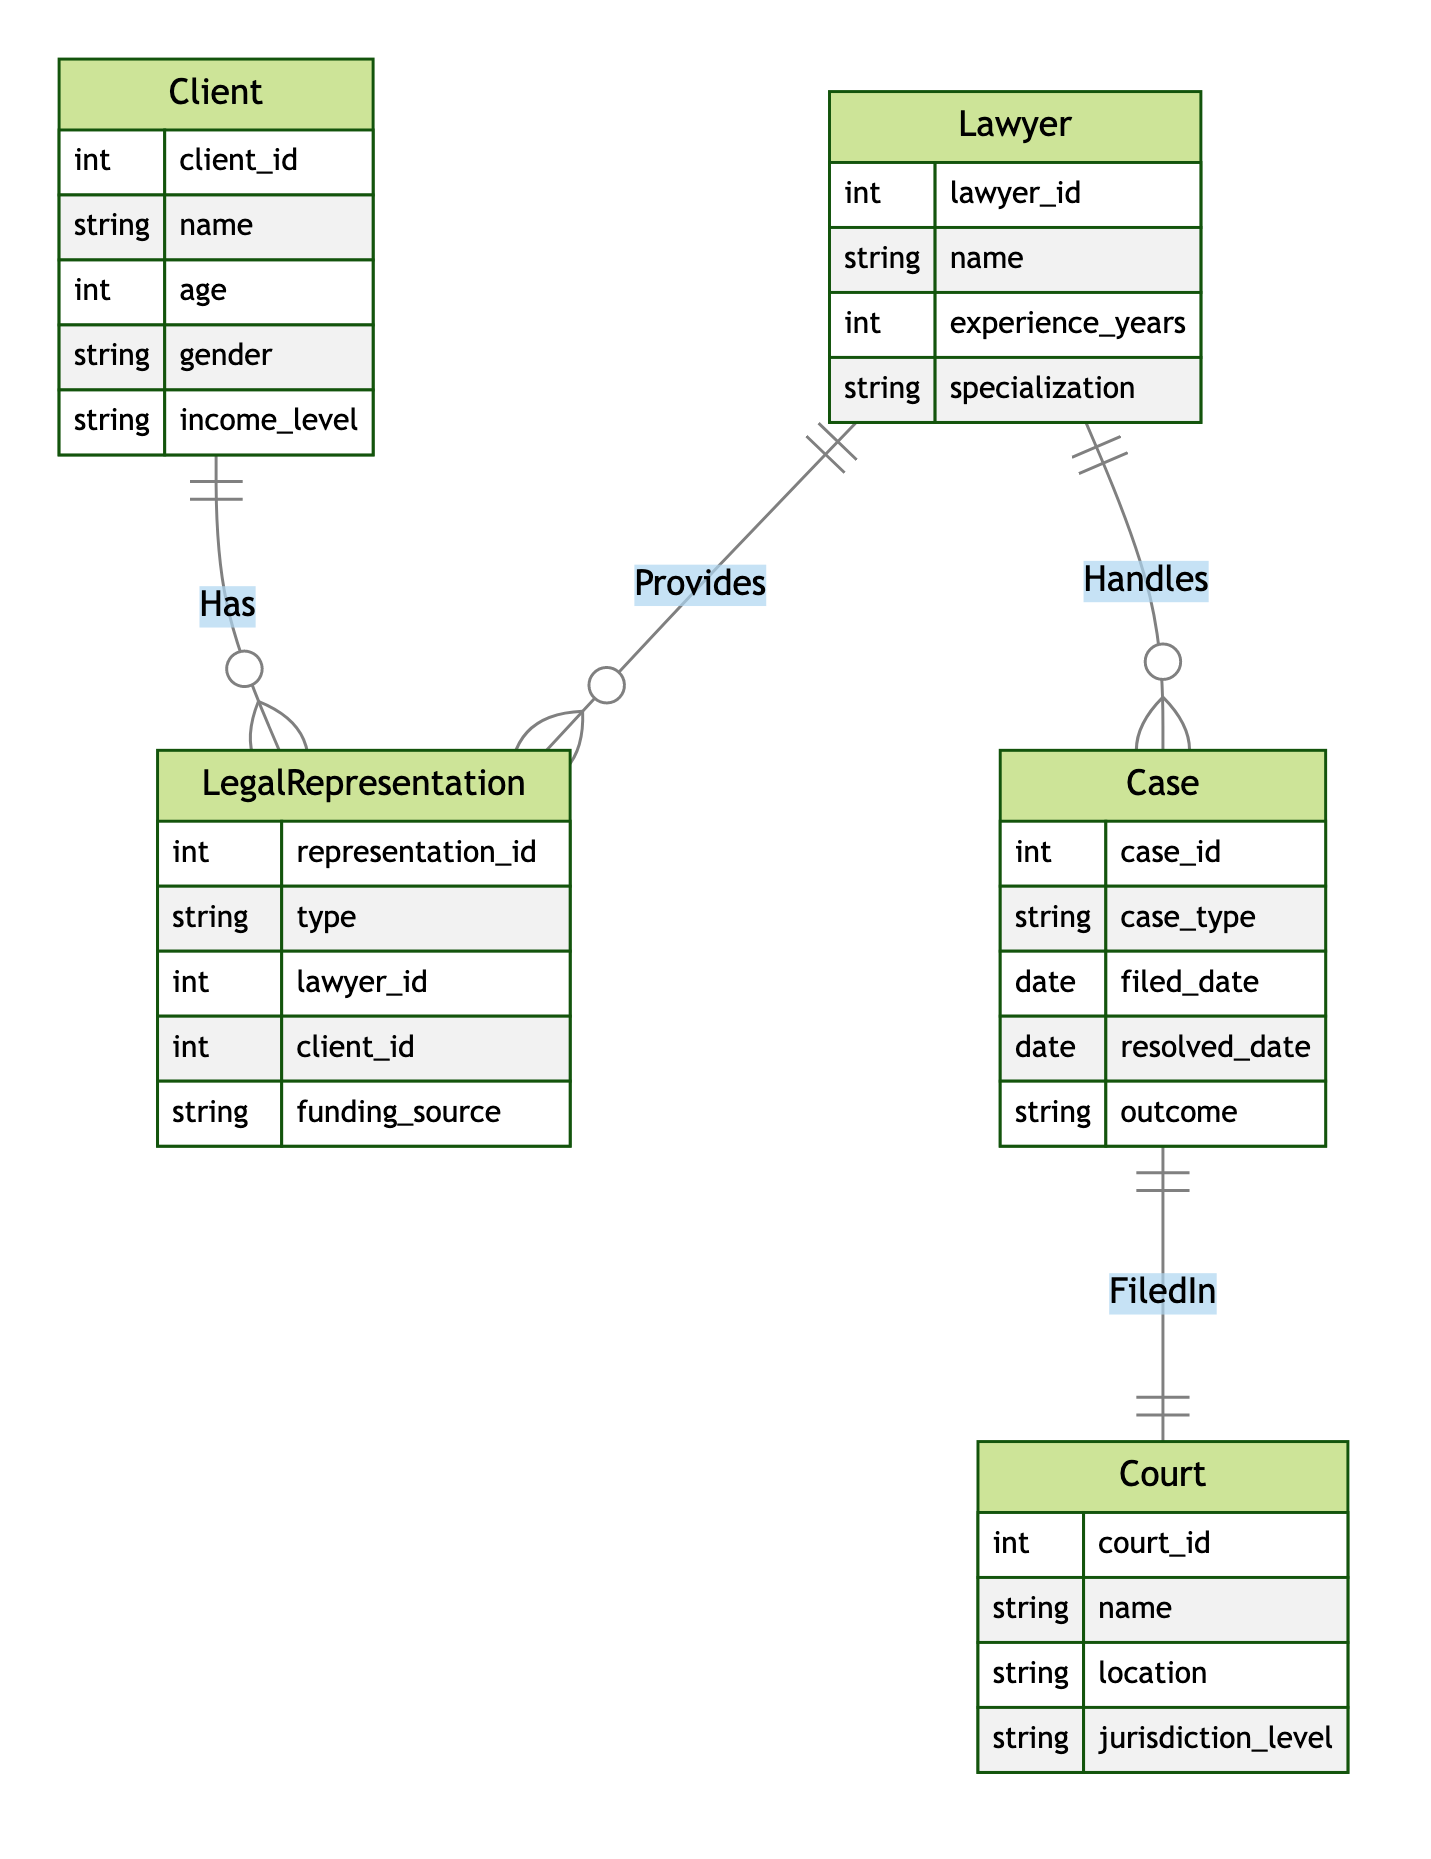What is the primary relationship between Lawyer and Client? In the diagram, the relationship is labeled "Represents", which indicates that a lawyer represents a client as part of their legal representation.
Answer: Represents How many attributes are associated with the Case entity? The Case entity has five attributes: case_id, case_type, filed_date, resolved_date, and outcome. Counting these yields a total of five attributes.
Answer: 5 What is the funding source for LegalRepresentation? The LegalRepresentation entity includes an attribute called funding_source, indicating where the financing for the legal representation comes from.
Answer: funding_source Which entity has an attribute named age? The Client entity contains the attribute named age, which provides demographic information about the client.
Answer: Client What relationships does the Lawyer entity participate in? The Lawyer entity participates in two relationships: "Represents" with the Client entity and "Handles" with the Case entity. This shows the dual role of lawyers in representing clients and managing cases.
Answer: Represents, Handles Which entity is connected to the Case entity through the FiledIn relationship? The Case entity is connected to the Court entity through the FiledIn relationship, which indicates that the case is filed in a specific court.
Answer: Court How many entities are represented in the diagram? There are five entities represented in the diagram: Client, LegalRepresentation, Lawyer, Case, and Court. Counting these gives a total of five entities.
Answer: 5 What type of relationship exists between Court and Case? The relationship between Court and Case is labeled "FiledIn", indicating that cases are filed in courts.
Answer: FiledIn How does the LegalRepresentation entity relate to the Client? The LegalRepresentation entity relates to the Client through the "Has" relationship, which signifies that clients have legal representation.
Answer: Has What is the relationship type that connects Lawyer to Case? The relationship type that connects Lawyer to Case is "Handles", showing that lawyers handle or are responsible for cases.
Answer: Handles 